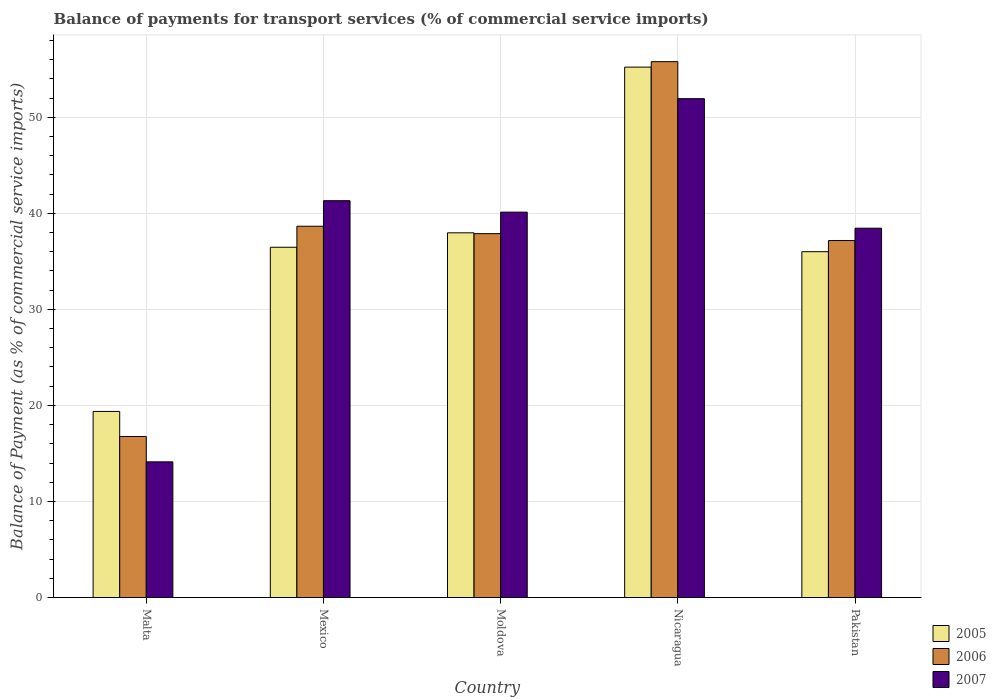How many groups of bars are there?
Your answer should be very brief. 5. Are the number of bars per tick equal to the number of legend labels?
Your answer should be very brief. Yes. Are the number of bars on each tick of the X-axis equal?
Your response must be concise. Yes. How many bars are there on the 5th tick from the left?
Offer a terse response. 3. How many bars are there on the 5th tick from the right?
Your answer should be very brief. 3. What is the label of the 1st group of bars from the left?
Your answer should be compact. Malta. In how many cases, is the number of bars for a given country not equal to the number of legend labels?
Your answer should be very brief. 0. What is the balance of payments for transport services in 2006 in Malta?
Your response must be concise. 16.77. Across all countries, what is the maximum balance of payments for transport services in 2006?
Provide a short and direct response. 55.78. Across all countries, what is the minimum balance of payments for transport services in 2006?
Make the answer very short. 16.77. In which country was the balance of payments for transport services in 2005 maximum?
Your response must be concise. Nicaragua. In which country was the balance of payments for transport services in 2005 minimum?
Ensure brevity in your answer.  Malta. What is the total balance of payments for transport services in 2006 in the graph?
Offer a terse response. 186.25. What is the difference between the balance of payments for transport services in 2007 in Malta and that in Moldova?
Provide a short and direct response. -26. What is the difference between the balance of payments for transport services in 2005 in Malta and the balance of payments for transport services in 2007 in Mexico?
Keep it short and to the point. -21.94. What is the average balance of payments for transport services in 2005 per country?
Your answer should be very brief. 37.01. What is the difference between the balance of payments for transport services of/in 2007 and balance of payments for transport services of/in 2006 in Mexico?
Make the answer very short. 2.66. In how many countries, is the balance of payments for transport services in 2006 greater than 4 %?
Ensure brevity in your answer.  5. What is the ratio of the balance of payments for transport services in 2006 in Malta to that in Nicaragua?
Make the answer very short. 0.3. Is the difference between the balance of payments for transport services in 2007 in Malta and Moldova greater than the difference between the balance of payments for transport services in 2006 in Malta and Moldova?
Provide a short and direct response. No. What is the difference between the highest and the second highest balance of payments for transport services in 2006?
Offer a very short reply. -0.77. What is the difference between the highest and the lowest balance of payments for transport services in 2005?
Give a very brief answer. 35.84. What does the 1st bar from the left in Mexico represents?
Your answer should be very brief. 2005. What does the 1st bar from the right in Mexico represents?
Offer a very short reply. 2007. How many bars are there?
Offer a very short reply. 15. Are all the bars in the graph horizontal?
Make the answer very short. No. What is the difference between two consecutive major ticks on the Y-axis?
Keep it short and to the point. 10. Does the graph contain any zero values?
Provide a short and direct response. No. Where does the legend appear in the graph?
Give a very brief answer. Bottom right. How are the legend labels stacked?
Provide a succinct answer. Vertical. What is the title of the graph?
Keep it short and to the point. Balance of payments for transport services (% of commercial service imports). Does "2003" appear as one of the legend labels in the graph?
Your response must be concise. No. What is the label or title of the Y-axis?
Provide a short and direct response. Balance of Payment (as % of commercial service imports). What is the Balance of Payment (as % of commercial service imports) in 2005 in Malta?
Provide a short and direct response. 19.37. What is the Balance of Payment (as % of commercial service imports) of 2006 in Malta?
Provide a succinct answer. 16.77. What is the Balance of Payment (as % of commercial service imports) of 2007 in Malta?
Give a very brief answer. 14.12. What is the Balance of Payment (as % of commercial service imports) in 2005 in Mexico?
Provide a short and direct response. 36.46. What is the Balance of Payment (as % of commercial service imports) of 2006 in Mexico?
Your answer should be very brief. 38.65. What is the Balance of Payment (as % of commercial service imports) in 2007 in Mexico?
Your response must be concise. 41.31. What is the Balance of Payment (as % of commercial service imports) in 2005 in Moldova?
Your answer should be compact. 37.97. What is the Balance of Payment (as % of commercial service imports) in 2006 in Moldova?
Your answer should be very brief. 37.88. What is the Balance of Payment (as % of commercial service imports) of 2007 in Moldova?
Your answer should be very brief. 40.12. What is the Balance of Payment (as % of commercial service imports) in 2005 in Nicaragua?
Offer a terse response. 55.22. What is the Balance of Payment (as % of commercial service imports) in 2006 in Nicaragua?
Give a very brief answer. 55.78. What is the Balance of Payment (as % of commercial service imports) in 2007 in Nicaragua?
Give a very brief answer. 51.93. What is the Balance of Payment (as % of commercial service imports) in 2005 in Pakistan?
Offer a very short reply. 36. What is the Balance of Payment (as % of commercial service imports) in 2006 in Pakistan?
Make the answer very short. 37.16. What is the Balance of Payment (as % of commercial service imports) in 2007 in Pakistan?
Your answer should be compact. 38.45. Across all countries, what is the maximum Balance of Payment (as % of commercial service imports) in 2005?
Your answer should be compact. 55.22. Across all countries, what is the maximum Balance of Payment (as % of commercial service imports) of 2006?
Your answer should be compact. 55.78. Across all countries, what is the maximum Balance of Payment (as % of commercial service imports) of 2007?
Give a very brief answer. 51.93. Across all countries, what is the minimum Balance of Payment (as % of commercial service imports) in 2005?
Keep it short and to the point. 19.37. Across all countries, what is the minimum Balance of Payment (as % of commercial service imports) in 2006?
Provide a succinct answer. 16.77. Across all countries, what is the minimum Balance of Payment (as % of commercial service imports) in 2007?
Your answer should be very brief. 14.12. What is the total Balance of Payment (as % of commercial service imports) of 2005 in the graph?
Offer a very short reply. 185.03. What is the total Balance of Payment (as % of commercial service imports) in 2006 in the graph?
Provide a succinct answer. 186.25. What is the total Balance of Payment (as % of commercial service imports) of 2007 in the graph?
Keep it short and to the point. 185.94. What is the difference between the Balance of Payment (as % of commercial service imports) in 2005 in Malta and that in Mexico?
Your response must be concise. -17.09. What is the difference between the Balance of Payment (as % of commercial service imports) in 2006 in Malta and that in Mexico?
Your response must be concise. -21.89. What is the difference between the Balance of Payment (as % of commercial service imports) in 2007 in Malta and that in Mexico?
Provide a succinct answer. -27.19. What is the difference between the Balance of Payment (as % of commercial service imports) in 2005 in Malta and that in Moldova?
Give a very brief answer. -18.59. What is the difference between the Balance of Payment (as % of commercial service imports) in 2006 in Malta and that in Moldova?
Offer a very short reply. -21.12. What is the difference between the Balance of Payment (as % of commercial service imports) of 2007 in Malta and that in Moldova?
Offer a terse response. -26. What is the difference between the Balance of Payment (as % of commercial service imports) of 2005 in Malta and that in Nicaragua?
Your answer should be very brief. -35.84. What is the difference between the Balance of Payment (as % of commercial service imports) of 2006 in Malta and that in Nicaragua?
Keep it short and to the point. -39.02. What is the difference between the Balance of Payment (as % of commercial service imports) in 2007 in Malta and that in Nicaragua?
Offer a very short reply. -37.81. What is the difference between the Balance of Payment (as % of commercial service imports) in 2005 in Malta and that in Pakistan?
Offer a very short reply. -16.63. What is the difference between the Balance of Payment (as % of commercial service imports) of 2006 in Malta and that in Pakistan?
Offer a terse response. -20.4. What is the difference between the Balance of Payment (as % of commercial service imports) of 2007 in Malta and that in Pakistan?
Your answer should be very brief. -24.32. What is the difference between the Balance of Payment (as % of commercial service imports) in 2005 in Mexico and that in Moldova?
Provide a short and direct response. -1.5. What is the difference between the Balance of Payment (as % of commercial service imports) of 2006 in Mexico and that in Moldova?
Provide a short and direct response. 0.77. What is the difference between the Balance of Payment (as % of commercial service imports) of 2007 in Mexico and that in Moldova?
Ensure brevity in your answer.  1.19. What is the difference between the Balance of Payment (as % of commercial service imports) in 2005 in Mexico and that in Nicaragua?
Your answer should be very brief. -18.75. What is the difference between the Balance of Payment (as % of commercial service imports) in 2006 in Mexico and that in Nicaragua?
Provide a succinct answer. -17.13. What is the difference between the Balance of Payment (as % of commercial service imports) in 2007 in Mexico and that in Nicaragua?
Make the answer very short. -10.62. What is the difference between the Balance of Payment (as % of commercial service imports) of 2005 in Mexico and that in Pakistan?
Offer a terse response. 0.46. What is the difference between the Balance of Payment (as % of commercial service imports) of 2006 in Mexico and that in Pakistan?
Your answer should be very brief. 1.49. What is the difference between the Balance of Payment (as % of commercial service imports) in 2007 in Mexico and that in Pakistan?
Your answer should be very brief. 2.86. What is the difference between the Balance of Payment (as % of commercial service imports) of 2005 in Moldova and that in Nicaragua?
Provide a succinct answer. -17.25. What is the difference between the Balance of Payment (as % of commercial service imports) in 2006 in Moldova and that in Nicaragua?
Your answer should be compact. -17.9. What is the difference between the Balance of Payment (as % of commercial service imports) in 2007 in Moldova and that in Nicaragua?
Provide a succinct answer. -11.81. What is the difference between the Balance of Payment (as % of commercial service imports) in 2005 in Moldova and that in Pakistan?
Your answer should be very brief. 1.96. What is the difference between the Balance of Payment (as % of commercial service imports) of 2006 in Moldova and that in Pakistan?
Your response must be concise. 0.72. What is the difference between the Balance of Payment (as % of commercial service imports) of 2007 in Moldova and that in Pakistan?
Your response must be concise. 1.67. What is the difference between the Balance of Payment (as % of commercial service imports) of 2005 in Nicaragua and that in Pakistan?
Provide a short and direct response. 19.21. What is the difference between the Balance of Payment (as % of commercial service imports) in 2006 in Nicaragua and that in Pakistan?
Your answer should be very brief. 18.62. What is the difference between the Balance of Payment (as % of commercial service imports) of 2007 in Nicaragua and that in Pakistan?
Keep it short and to the point. 13.48. What is the difference between the Balance of Payment (as % of commercial service imports) of 2005 in Malta and the Balance of Payment (as % of commercial service imports) of 2006 in Mexico?
Make the answer very short. -19.28. What is the difference between the Balance of Payment (as % of commercial service imports) of 2005 in Malta and the Balance of Payment (as % of commercial service imports) of 2007 in Mexico?
Offer a terse response. -21.94. What is the difference between the Balance of Payment (as % of commercial service imports) of 2006 in Malta and the Balance of Payment (as % of commercial service imports) of 2007 in Mexico?
Ensure brevity in your answer.  -24.55. What is the difference between the Balance of Payment (as % of commercial service imports) in 2005 in Malta and the Balance of Payment (as % of commercial service imports) in 2006 in Moldova?
Your answer should be very brief. -18.51. What is the difference between the Balance of Payment (as % of commercial service imports) in 2005 in Malta and the Balance of Payment (as % of commercial service imports) in 2007 in Moldova?
Offer a terse response. -20.75. What is the difference between the Balance of Payment (as % of commercial service imports) of 2006 in Malta and the Balance of Payment (as % of commercial service imports) of 2007 in Moldova?
Ensure brevity in your answer.  -23.35. What is the difference between the Balance of Payment (as % of commercial service imports) of 2005 in Malta and the Balance of Payment (as % of commercial service imports) of 2006 in Nicaragua?
Give a very brief answer. -36.41. What is the difference between the Balance of Payment (as % of commercial service imports) in 2005 in Malta and the Balance of Payment (as % of commercial service imports) in 2007 in Nicaragua?
Offer a terse response. -32.56. What is the difference between the Balance of Payment (as % of commercial service imports) of 2006 in Malta and the Balance of Payment (as % of commercial service imports) of 2007 in Nicaragua?
Offer a terse response. -35.17. What is the difference between the Balance of Payment (as % of commercial service imports) in 2005 in Malta and the Balance of Payment (as % of commercial service imports) in 2006 in Pakistan?
Provide a succinct answer. -17.79. What is the difference between the Balance of Payment (as % of commercial service imports) in 2005 in Malta and the Balance of Payment (as % of commercial service imports) in 2007 in Pakistan?
Your answer should be compact. -19.07. What is the difference between the Balance of Payment (as % of commercial service imports) of 2006 in Malta and the Balance of Payment (as % of commercial service imports) of 2007 in Pakistan?
Keep it short and to the point. -21.68. What is the difference between the Balance of Payment (as % of commercial service imports) of 2005 in Mexico and the Balance of Payment (as % of commercial service imports) of 2006 in Moldova?
Provide a short and direct response. -1.42. What is the difference between the Balance of Payment (as % of commercial service imports) of 2005 in Mexico and the Balance of Payment (as % of commercial service imports) of 2007 in Moldova?
Give a very brief answer. -3.66. What is the difference between the Balance of Payment (as % of commercial service imports) of 2006 in Mexico and the Balance of Payment (as % of commercial service imports) of 2007 in Moldova?
Your response must be concise. -1.47. What is the difference between the Balance of Payment (as % of commercial service imports) in 2005 in Mexico and the Balance of Payment (as % of commercial service imports) in 2006 in Nicaragua?
Provide a short and direct response. -19.32. What is the difference between the Balance of Payment (as % of commercial service imports) in 2005 in Mexico and the Balance of Payment (as % of commercial service imports) in 2007 in Nicaragua?
Make the answer very short. -15.47. What is the difference between the Balance of Payment (as % of commercial service imports) of 2006 in Mexico and the Balance of Payment (as % of commercial service imports) of 2007 in Nicaragua?
Your answer should be compact. -13.28. What is the difference between the Balance of Payment (as % of commercial service imports) of 2005 in Mexico and the Balance of Payment (as % of commercial service imports) of 2006 in Pakistan?
Your response must be concise. -0.7. What is the difference between the Balance of Payment (as % of commercial service imports) in 2005 in Mexico and the Balance of Payment (as % of commercial service imports) in 2007 in Pakistan?
Your answer should be compact. -1.98. What is the difference between the Balance of Payment (as % of commercial service imports) in 2006 in Mexico and the Balance of Payment (as % of commercial service imports) in 2007 in Pakistan?
Provide a succinct answer. 0.2. What is the difference between the Balance of Payment (as % of commercial service imports) in 2005 in Moldova and the Balance of Payment (as % of commercial service imports) in 2006 in Nicaragua?
Ensure brevity in your answer.  -17.82. What is the difference between the Balance of Payment (as % of commercial service imports) in 2005 in Moldova and the Balance of Payment (as % of commercial service imports) in 2007 in Nicaragua?
Offer a terse response. -13.96. What is the difference between the Balance of Payment (as % of commercial service imports) of 2006 in Moldova and the Balance of Payment (as % of commercial service imports) of 2007 in Nicaragua?
Your response must be concise. -14.05. What is the difference between the Balance of Payment (as % of commercial service imports) in 2005 in Moldova and the Balance of Payment (as % of commercial service imports) in 2006 in Pakistan?
Your response must be concise. 0.8. What is the difference between the Balance of Payment (as % of commercial service imports) of 2005 in Moldova and the Balance of Payment (as % of commercial service imports) of 2007 in Pakistan?
Your answer should be compact. -0.48. What is the difference between the Balance of Payment (as % of commercial service imports) in 2006 in Moldova and the Balance of Payment (as % of commercial service imports) in 2007 in Pakistan?
Your response must be concise. -0.57. What is the difference between the Balance of Payment (as % of commercial service imports) in 2005 in Nicaragua and the Balance of Payment (as % of commercial service imports) in 2006 in Pakistan?
Keep it short and to the point. 18.05. What is the difference between the Balance of Payment (as % of commercial service imports) of 2005 in Nicaragua and the Balance of Payment (as % of commercial service imports) of 2007 in Pakistan?
Keep it short and to the point. 16.77. What is the difference between the Balance of Payment (as % of commercial service imports) of 2006 in Nicaragua and the Balance of Payment (as % of commercial service imports) of 2007 in Pakistan?
Ensure brevity in your answer.  17.34. What is the average Balance of Payment (as % of commercial service imports) of 2005 per country?
Offer a very short reply. 37.01. What is the average Balance of Payment (as % of commercial service imports) in 2006 per country?
Offer a very short reply. 37.25. What is the average Balance of Payment (as % of commercial service imports) of 2007 per country?
Your answer should be compact. 37.19. What is the difference between the Balance of Payment (as % of commercial service imports) in 2005 and Balance of Payment (as % of commercial service imports) in 2006 in Malta?
Ensure brevity in your answer.  2.61. What is the difference between the Balance of Payment (as % of commercial service imports) in 2005 and Balance of Payment (as % of commercial service imports) in 2007 in Malta?
Ensure brevity in your answer.  5.25. What is the difference between the Balance of Payment (as % of commercial service imports) of 2006 and Balance of Payment (as % of commercial service imports) of 2007 in Malta?
Your answer should be compact. 2.64. What is the difference between the Balance of Payment (as % of commercial service imports) of 2005 and Balance of Payment (as % of commercial service imports) of 2006 in Mexico?
Your answer should be compact. -2.19. What is the difference between the Balance of Payment (as % of commercial service imports) in 2005 and Balance of Payment (as % of commercial service imports) in 2007 in Mexico?
Your answer should be compact. -4.85. What is the difference between the Balance of Payment (as % of commercial service imports) in 2006 and Balance of Payment (as % of commercial service imports) in 2007 in Mexico?
Make the answer very short. -2.66. What is the difference between the Balance of Payment (as % of commercial service imports) of 2005 and Balance of Payment (as % of commercial service imports) of 2006 in Moldova?
Your answer should be very brief. 0.09. What is the difference between the Balance of Payment (as % of commercial service imports) of 2005 and Balance of Payment (as % of commercial service imports) of 2007 in Moldova?
Offer a very short reply. -2.15. What is the difference between the Balance of Payment (as % of commercial service imports) in 2006 and Balance of Payment (as % of commercial service imports) in 2007 in Moldova?
Offer a very short reply. -2.24. What is the difference between the Balance of Payment (as % of commercial service imports) of 2005 and Balance of Payment (as % of commercial service imports) of 2006 in Nicaragua?
Your answer should be very brief. -0.57. What is the difference between the Balance of Payment (as % of commercial service imports) in 2005 and Balance of Payment (as % of commercial service imports) in 2007 in Nicaragua?
Your response must be concise. 3.29. What is the difference between the Balance of Payment (as % of commercial service imports) in 2006 and Balance of Payment (as % of commercial service imports) in 2007 in Nicaragua?
Offer a very short reply. 3.85. What is the difference between the Balance of Payment (as % of commercial service imports) in 2005 and Balance of Payment (as % of commercial service imports) in 2006 in Pakistan?
Give a very brief answer. -1.16. What is the difference between the Balance of Payment (as % of commercial service imports) of 2005 and Balance of Payment (as % of commercial service imports) of 2007 in Pakistan?
Ensure brevity in your answer.  -2.44. What is the difference between the Balance of Payment (as % of commercial service imports) of 2006 and Balance of Payment (as % of commercial service imports) of 2007 in Pakistan?
Provide a short and direct response. -1.28. What is the ratio of the Balance of Payment (as % of commercial service imports) in 2005 in Malta to that in Mexico?
Provide a short and direct response. 0.53. What is the ratio of the Balance of Payment (as % of commercial service imports) in 2006 in Malta to that in Mexico?
Provide a short and direct response. 0.43. What is the ratio of the Balance of Payment (as % of commercial service imports) in 2007 in Malta to that in Mexico?
Make the answer very short. 0.34. What is the ratio of the Balance of Payment (as % of commercial service imports) in 2005 in Malta to that in Moldova?
Ensure brevity in your answer.  0.51. What is the ratio of the Balance of Payment (as % of commercial service imports) in 2006 in Malta to that in Moldova?
Ensure brevity in your answer.  0.44. What is the ratio of the Balance of Payment (as % of commercial service imports) of 2007 in Malta to that in Moldova?
Your answer should be compact. 0.35. What is the ratio of the Balance of Payment (as % of commercial service imports) in 2005 in Malta to that in Nicaragua?
Your answer should be very brief. 0.35. What is the ratio of the Balance of Payment (as % of commercial service imports) of 2006 in Malta to that in Nicaragua?
Your answer should be very brief. 0.3. What is the ratio of the Balance of Payment (as % of commercial service imports) of 2007 in Malta to that in Nicaragua?
Make the answer very short. 0.27. What is the ratio of the Balance of Payment (as % of commercial service imports) in 2005 in Malta to that in Pakistan?
Provide a succinct answer. 0.54. What is the ratio of the Balance of Payment (as % of commercial service imports) of 2006 in Malta to that in Pakistan?
Offer a terse response. 0.45. What is the ratio of the Balance of Payment (as % of commercial service imports) of 2007 in Malta to that in Pakistan?
Keep it short and to the point. 0.37. What is the ratio of the Balance of Payment (as % of commercial service imports) of 2005 in Mexico to that in Moldova?
Provide a short and direct response. 0.96. What is the ratio of the Balance of Payment (as % of commercial service imports) of 2006 in Mexico to that in Moldova?
Your answer should be very brief. 1.02. What is the ratio of the Balance of Payment (as % of commercial service imports) of 2007 in Mexico to that in Moldova?
Offer a very short reply. 1.03. What is the ratio of the Balance of Payment (as % of commercial service imports) in 2005 in Mexico to that in Nicaragua?
Provide a succinct answer. 0.66. What is the ratio of the Balance of Payment (as % of commercial service imports) in 2006 in Mexico to that in Nicaragua?
Your response must be concise. 0.69. What is the ratio of the Balance of Payment (as % of commercial service imports) of 2007 in Mexico to that in Nicaragua?
Offer a terse response. 0.8. What is the ratio of the Balance of Payment (as % of commercial service imports) in 2005 in Mexico to that in Pakistan?
Provide a short and direct response. 1.01. What is the ratio of the Balance of Payment (as % of commercial service imports) in 2006 in Mexico to that in Pakistan?
Give a very brief answer. 1.04. What is the ratio of the Balance of Payment (as % of commercial service imports) in 2007 in Mexico to that in Pakistan?
Make the answer very short. 1.07. What is the ratio of the Balance of Payment (as % of commercial service imports) in 2005 in Moldova to that in Nicaragua?
Your answer should be very brief. 0.69. What is the ratio of the Balance of Payment (as % of commercial service imports) of 2006 in Moldova to that in Nicaragua?
Offer a very short reply. 0.68. What is the ratio of the Balance of Payment (as % of commercial service imports) of 2007 in Moldova to that in Nicaragua?
Your answer should be very brief. 0.77. What is the ratio of the Balance of Payment (as % of commercial service imports) of 2005 in Moldova to that in Pakistan?
Offer a very short reply. 1.05. What is the ratio of the Balance of Payment (as % of commercial service imports) in 2006 in Moldova to that in Pakistan?
Make the answer very short. 1.02. What is the ratio of the Balance of Payment (as % of commercial service imports) of 2007 in Moldova to that in Pakistan?
Make the answer very short. 1.04. What is the ratio of the Balance of Payment (as % of commercial service imports) in 2005 in Nicaragua to that in Pakistan?
Provide a succinct answer. 1.53. What is the ratio of the Balance of Payment (as % of commercial service imports) of 2006 in Nicaragua to that in Pakistan?
Keep it short and to the point. 1.5. What is the ratio of the Balance of Payment (as % of commercial service imports) in 2007 in Nicaragua to that in Pakistan?
Keep it short and to the point. 1.35. What is the difference between the highest and the second highest Balance of Payment (as % of commercial service imports) in 2005?
Your answer should be compact. 17.25. What is the difference between the highest and the second highest Balance of Payment (as % of commercial service imports) in 2006?
Provide a succinct answer. 17.13. What is the difference between the highest and the second highest Balance of Payment (as % of commercial service imports) in 2007?
Your response must be concise. 10.62. What is the difference between the highest and the lowest Balance of Payment (as % of commercial service imports) in 2005?
Your answer should be compact. 35.84. What is the difference between the highest and the lowest Balance of Payment (as % of commercial service imports) of 2006?
Provide a short and direct response. 39.02. What is the difference between the highest and the lowest Balance of Payment (as % of commercial service imports) of 2007?
Keep it short and to the point. 37.81. 